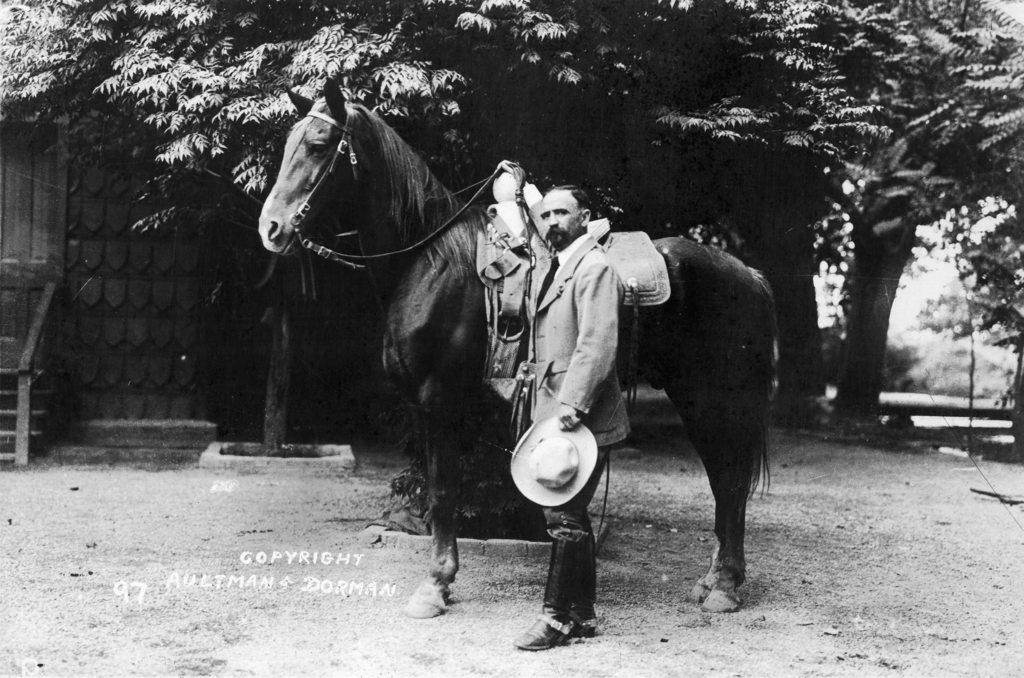Could you give a brief overview of what you see in this image? This is a black and white picture. Here we can see a man who is standing besides a horse. On the background there are trees. 